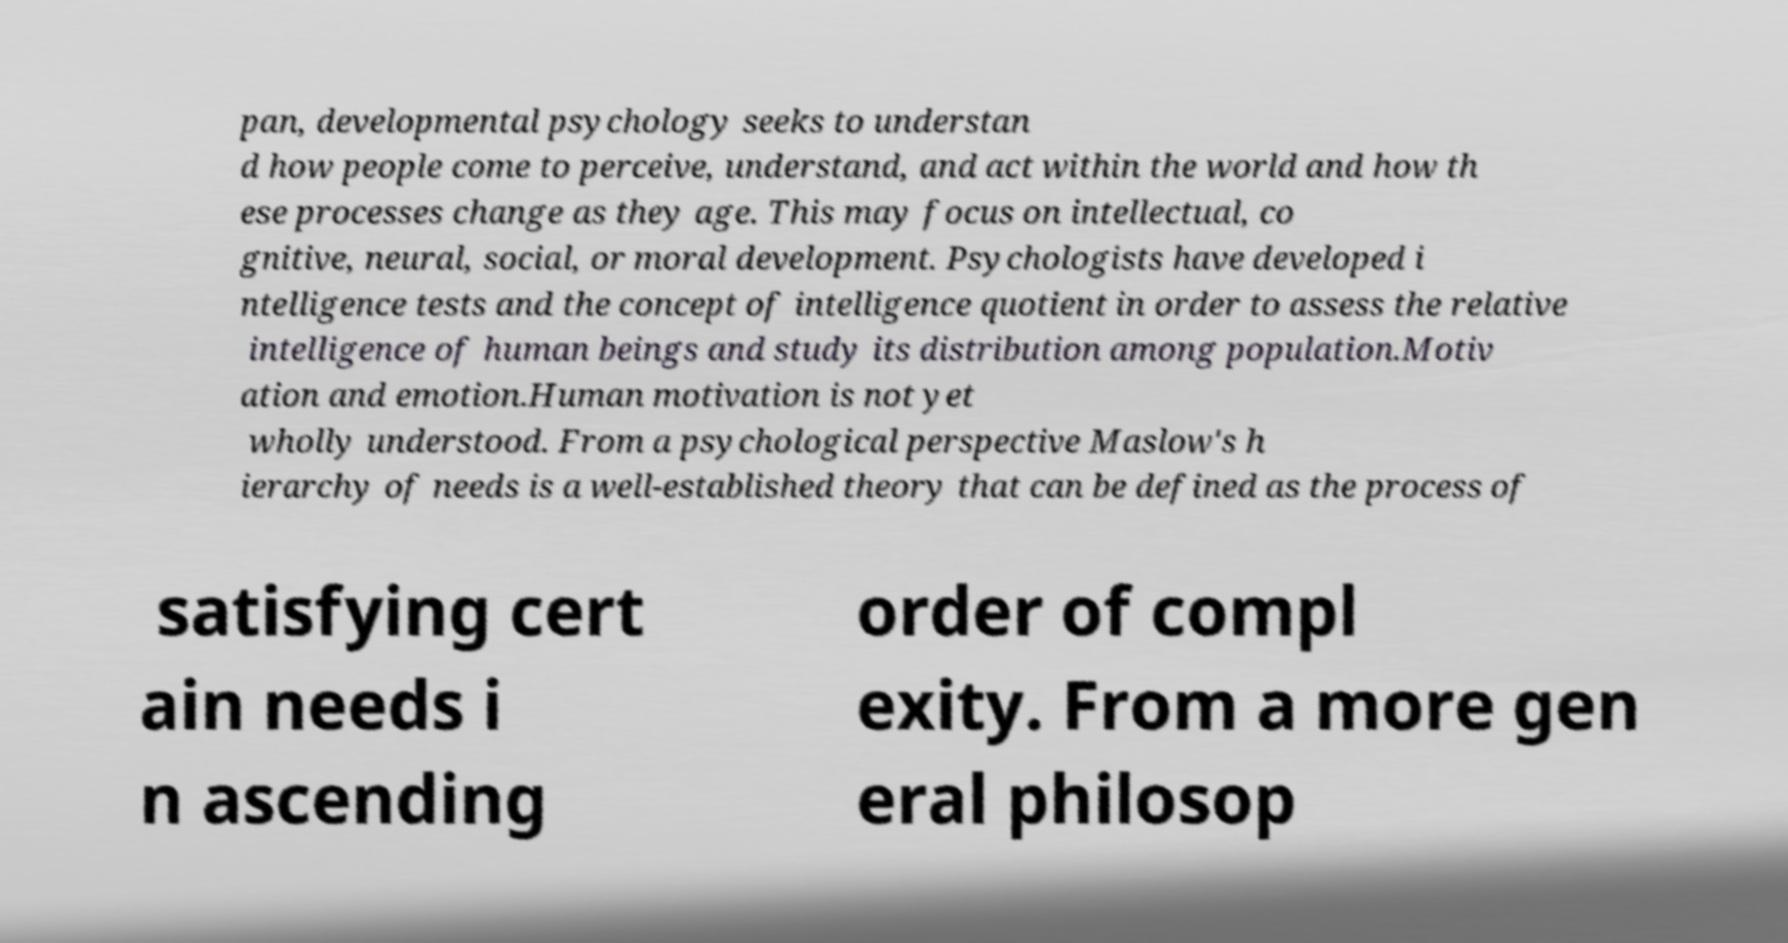There's text embedded in this image that I need extracted. Can you transcribe it verbatim? pan, developmental psychology seeks to understan d how people come to perceive, understand, and act within the world and how th ese processes change as they age. This may focus on intellectual, co gnitive, neural, social, or moral development. Psychologists have developed i ntelligence tests and the concept of intelligence quotient in order to assess the relative intelligence of human beings and study its distribution among population.Motiv ation and emotion.Human motivation is not yet wholly understood. From a psychological perspective Maslow's h ierarchy of needs is a well-established theory that can be defined as the process of satisfying cert ain needs i n ascending order of compl exity. From a more gen eral philosop 